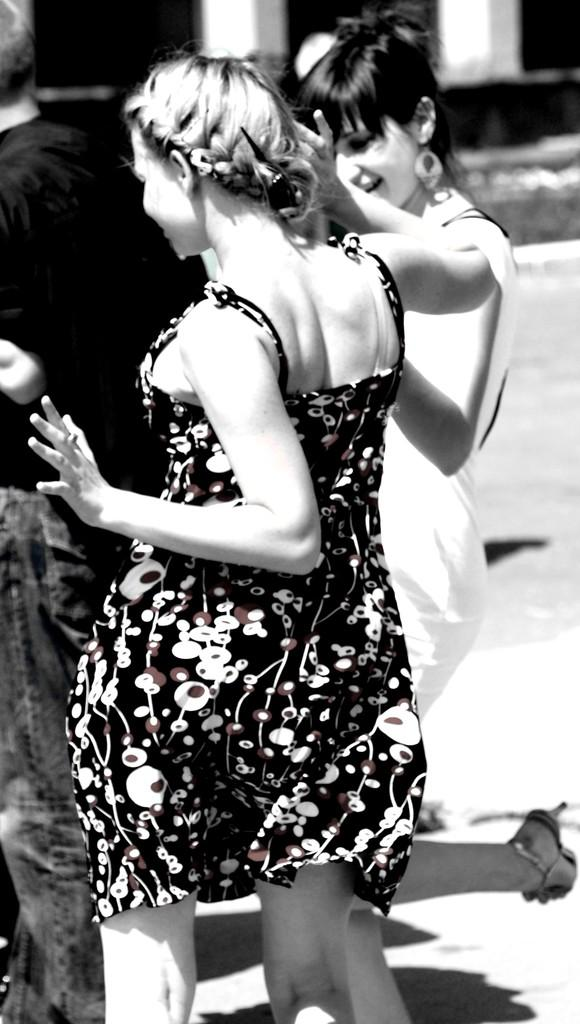What are the two women in the image doing? The two women are dancing in the image. Can you describe the facial expression of one of the people in the image? There is a person smiling in the image. What can be seen in the background of the image? There is a man, a walkway, and pillars in the background of the image. What invention can be seen in the hands of the women while they are dancing? There is no invention visible in the hands of the women while they are dancing; they are simply dancing. 